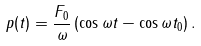Convert formula to latex. <formula><loc_0><loc_0><loc_500><loc_500>p ( t ) = \frac { F _ { 0 } } { \omega } \left ( \cos \omega t - \cos \omega t _ { 0 } \right ) .</formula> 